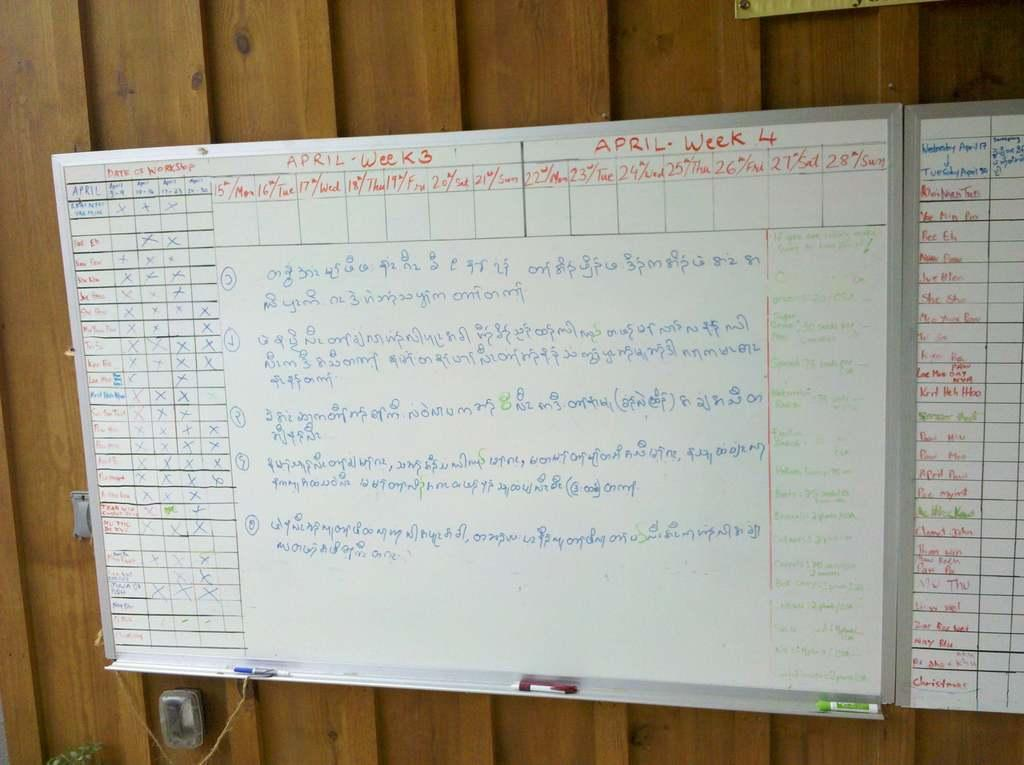<image>
Write a terse but informative summary of the picture. A whiteboard with writing in Arabic showing topics for week 3 and 4 of April 